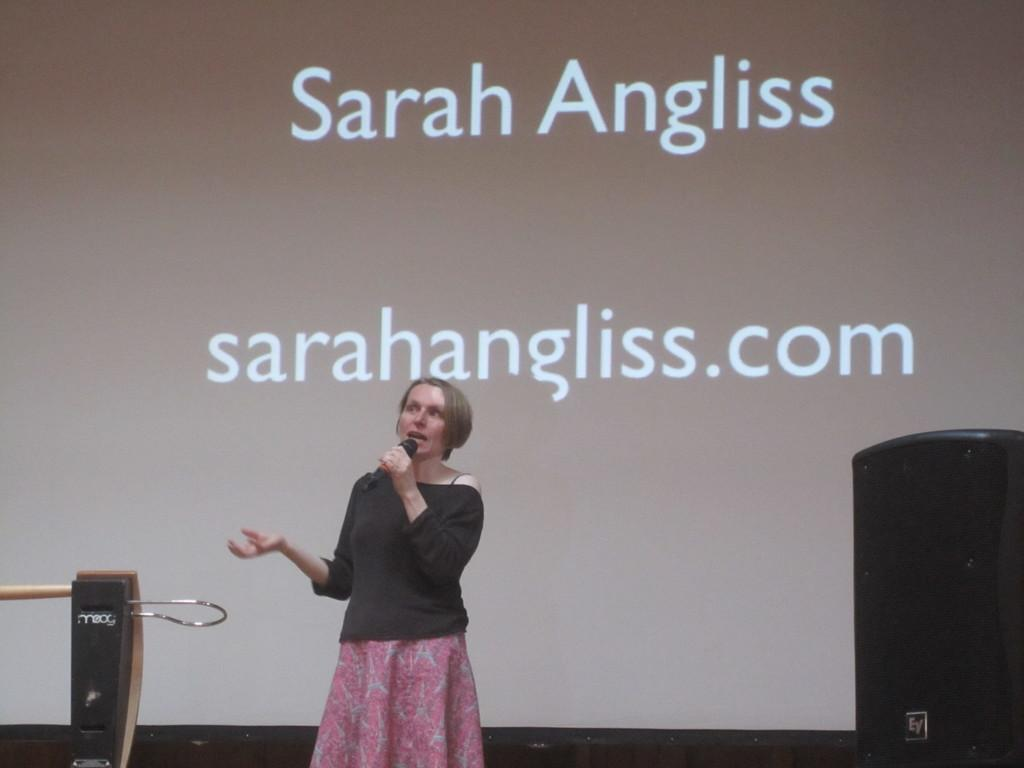Who is the main subject in the front of the image? There is a woman in the front of the image. What is the woman holding in the image? The woman is holding a microphone. What other object is present in the front of the image? There is a speaker in the front of the image. What can be seen in the background of the image? There is a screen in the background of the image. What is written on the screen? Something is written on the screen. What type of stick can be seen in the woman's hand in the image? There is no stick present in the woman's hand or in the image. 